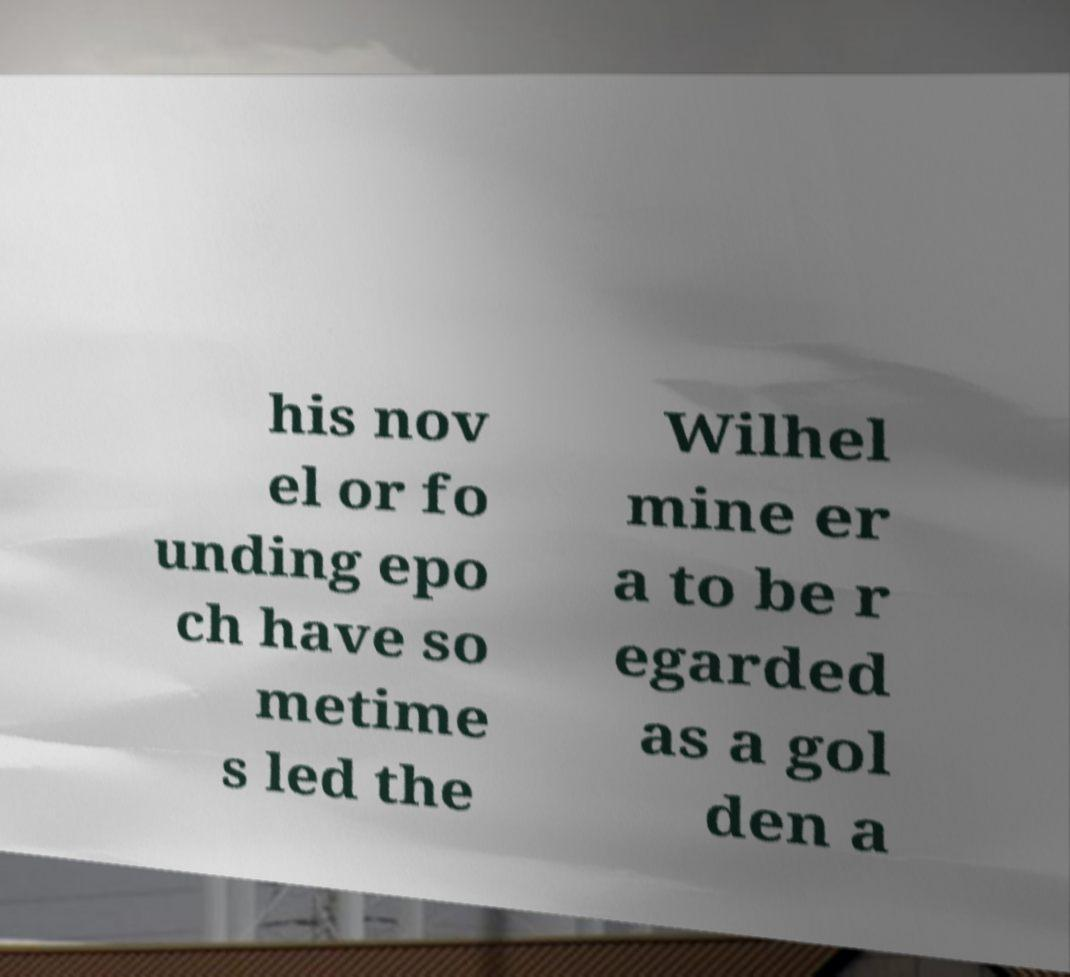For documentation purposes, I need the text within this image transcribed. Could you provide that? his nov el or fo unding epo ch have so metime s led the Wilhel mine er a to be r egarded as a gol den a 